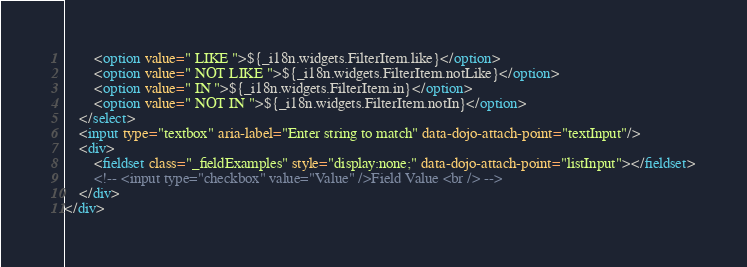Convert code to text. <code><loc_0><loc_0><loc_500><loc_500><_HTML_>		<option value=" LIKE ">${_i18n.widgets.FilterItem.like}</option>			
		<option value=" NOT LIKE ">${_i18n.widgets.FilterItem.notLike}</option>			
		<option value=" IN ">${_i18n.widgets.FilterItem.in}</option>			
		<option value=" NOT IN ">${_i18n.widgets.FilterItem.notIn}</option>			
	</select>
	<input type="textbox" aria-label="Enter string to match" data-dojo-attach-point="textInput"/>
	<div>
		<fieldset class="_fieldExamples" style="display:none;" data-dojo-attach-point="listInput"></fieldset>
		<!-- <input type="checkbox" value="Value" />Field Value <br /> -->
    </div>
</div></code> 